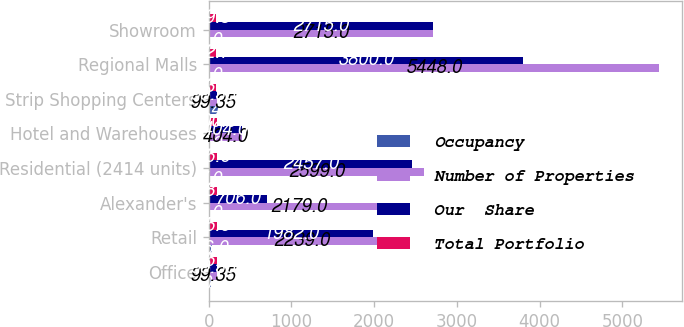<chart> <loc_0><loc_0><loc_500><loc_500><stacked_bar_chart><ecel><fcel>Office<fcel>Retail<fcel>Alexander's<fcel>Residential (2414 units)<fcel>Hotel and Warehouses<fcel>Strip Shopping Centers<fcel>Regional Malls<fcel>Showroom<nl><fcel>Occupancy<fcel>30<fcel>46<fcel>6<fcel>7<fcel>7<fcel>114<fcel>6<fcel>2<nl><fcel>Number of Properties<fcel>99.35<fcel>2239<fcel>2179<fcel>2599<fcel>404<fcel>99.35<fcel>5448<fcel>2715<nl><fcel>Our  Share<fcel>99.35<fcel>1982<fcel>706<fcel>2457<fcel>404<fcel>99.35<fcel>3800<fcel>2715<nl><fcel>Total Portfolio<fcel>96.2<fcel>95.6<fcel>98.7<fcel>96.6<fcel>100<fcel>93.3<fcel>92.7<fcel>89.8<nl></chart> 